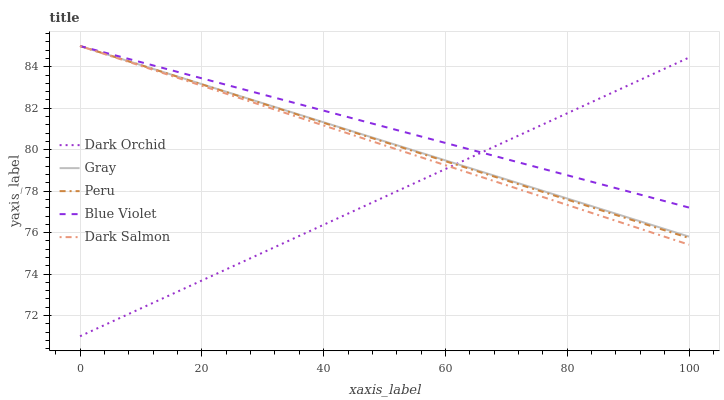Does Dark Orchid have the minimum area under the curve?
Answer yes or no. Yes. Does Blue Violet have the maximum area under the curve?
Answer yes or no. Yes. Does Gray have the minimum area under the curve?
Answer yes or no. No. Does Gray have the maximum area under the curve?
Answer yes or no. No. Is Gray the smoothest?
Answer yes or no. Yes. Is Dark Orchid the roughest?
Answer yes or no. Yes. Is Peru the smoothest?
Answer yes or no. No. Is Peru the roughest?
Answer yes or no. No. Does Dark Orchid have the lowest value?
Answer yes or no. Yes. Does Gray have the lowest value?
Answer yes or no. No. Does Dark Salmon have the highest value?
Answer yes or no. Yes. Does Dark Orchid have the highest value?
Answer yes or no. No. Does Blue Violet intersect Dark Orchid?
Answer yes or no. Yes. Is Blue Violet less than Dark Orchid?
Answer yes or no. No. Is Blue Violet greater than Dark Orchid?
Answer yes or no. No. 